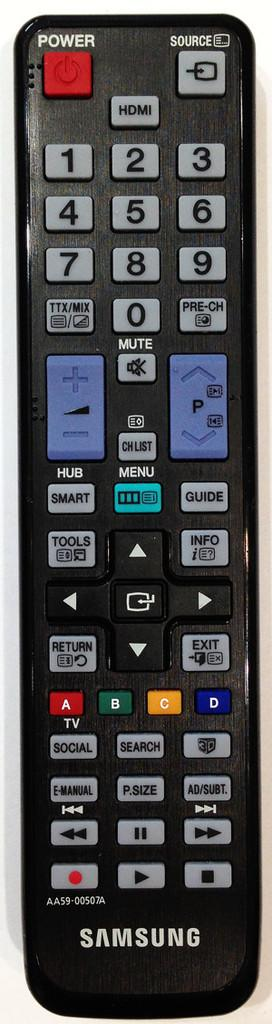Provide a one-sentence caption for the provided image. a Samsung remote control with the power and source buttons on the top where they should be, and other buttons like MUTE, MENU, TOOLS, EXIT, and others. 